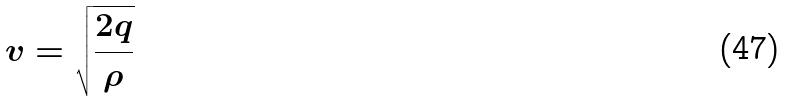<formula> <loc_0><loc_0><loc_500><loc_500>v = \sqrt { \frac { 2 q } { \rho } }</formula> 